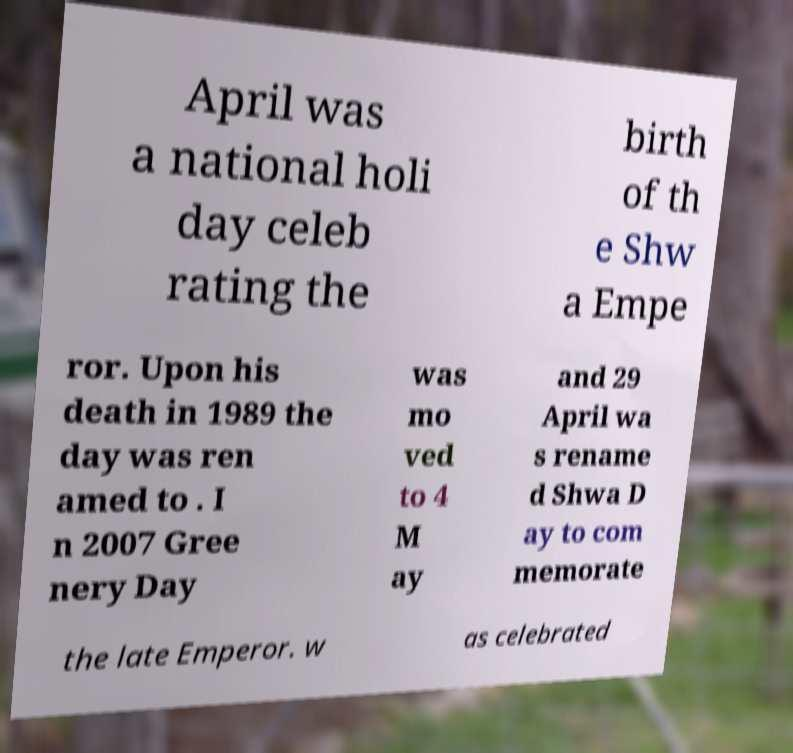Please identify and transcribe the text found in this image. April was a national holi day celeb rating the birth of th e Shw a Empe ror. Upon his death in 1989 the day was ren amed to . I n 2007 Gree nery Day was mo ved to 4 M ay and 29 April wa s rename d Shwa D ay to com memorate the late Emperor. w as celebrated 